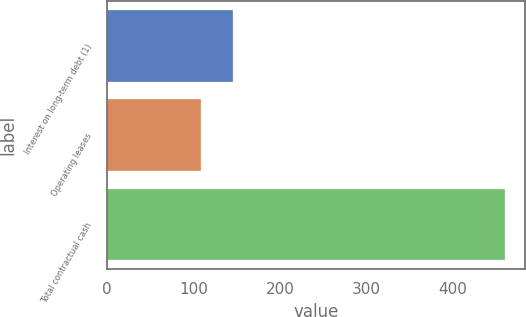Convert chart. <chart><loc_0><loc_0><loc_500><loc_500><bar_chart><fcel>Interest on long-term debt (1)<fcel>Operating leases<fcel>Total contractual cash<nl><fcel>145<fcel>109<fcel>460<nl></chart> 